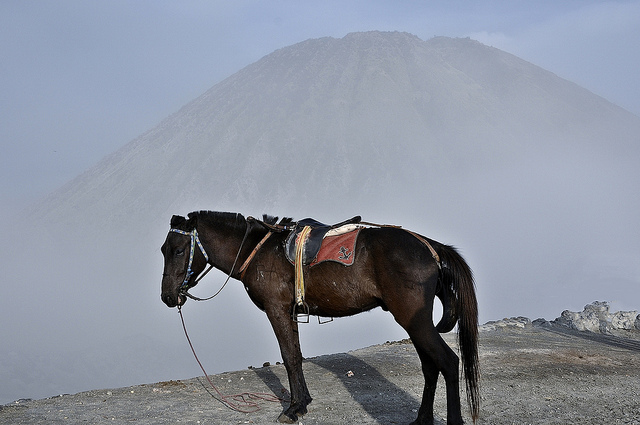<image>What breed of horse is this? I don't know what breed of horse this is. It can be 'thoroughbred', 'quarter horse', 'mare', 'arabian', 'appaloosa', or 'standard'. What breed of horse is this? I don't know what breed of horse is in the image. 